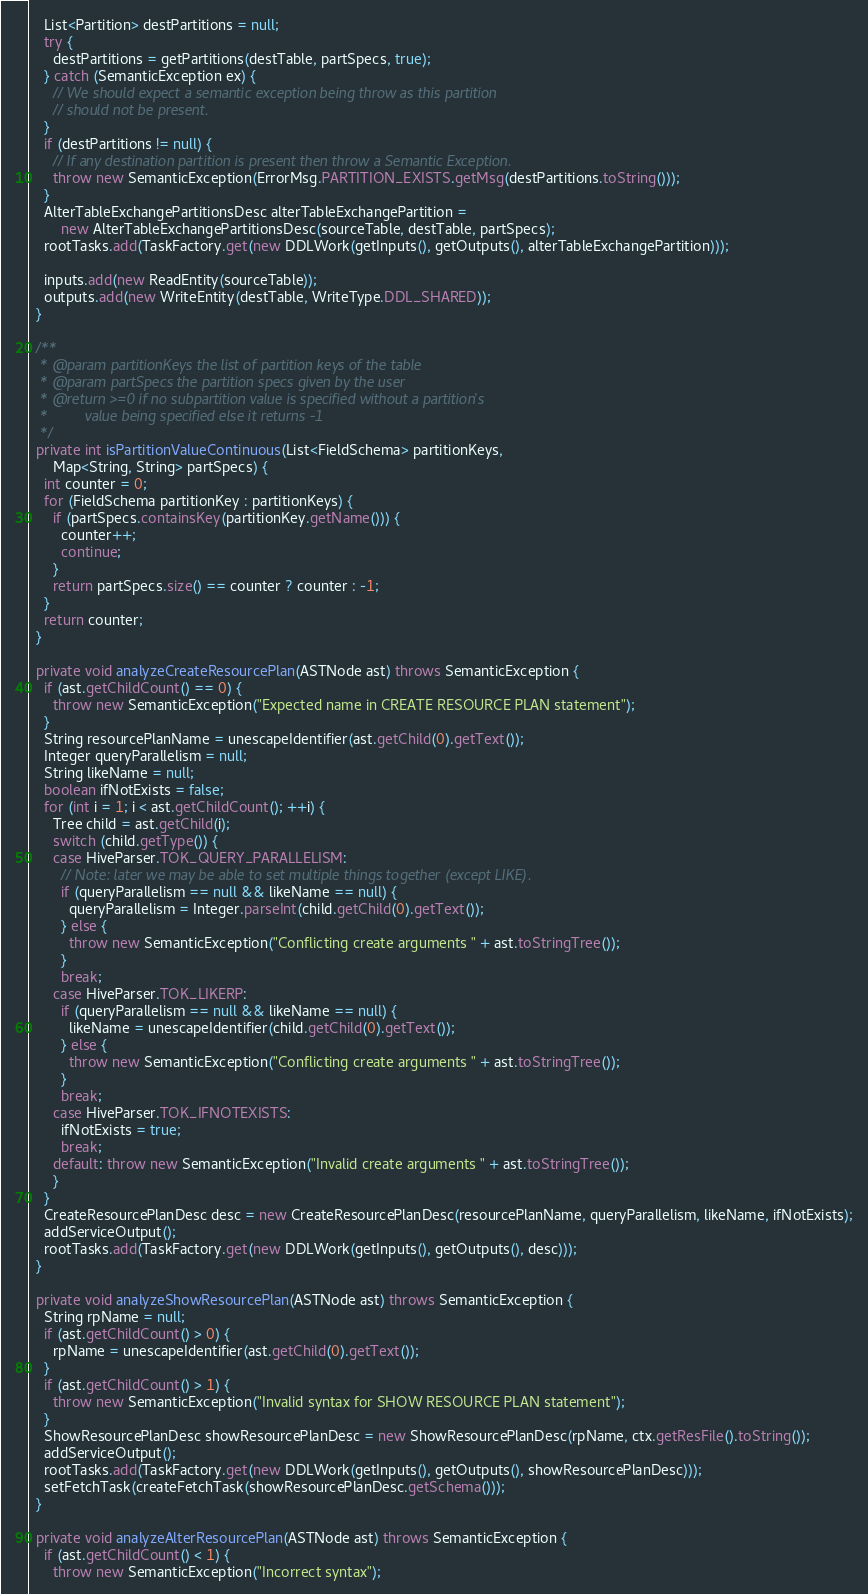Convert code to text. <code><loc_0><loc_0><loc_500><loc_500><_Java_>    List<Partition> destPartitions = null;
    try {
      destPartitions = getPartitions(destTable, partSpecs, true);
    } catch (SemanticException ex) {
      // We should expect a semantic exception being throw as this partition
      // should not be present.
    }
    if (destPartitions != null) {
      // If any destination partition is present then throw a Semantic Exception.
      throw new SemanticException(ErrorMsg.PARTITION_EXISTS.getMsg(destPartitions.toString()));
    }
    AlterTableExchangePartitionsDesc alterTableExchangePartition =
        new AlterTableExchangePartitionsDesc(sourceTable, destTable, partSpecs);
    rootTasks.add(TaskFactory.get(new DDLWork(getInputs(), getOutputs(), alterTableExchangePartition)));

    inputs.add(new ReadEntity(sourceTable));
    outputs.add(new WriteEntity(destTable, WriteType.DDL_SHARED));
  }

  /**
   * @param partitionKeys the list of partition keys of the table
   * @param partSpecs the partition specs given by the user
   * @return >=0 if no subpartition value is specified without a partition's
   *         value being specified else it returns -1
   */
  private int isPartitionValueContinuous(List<FieldSchema> partitionKeys,
      Map<String, String> partSpecs) {
    int counter = 0;
    for (FieldSchema partitionKey : partitionKeys) {
      if (partSpecs.containsKey(partitionKey.getName())) {
        counter++;
        continue;
      }
      return partSpecs.size() == counter ? counter : -1;
    }
    return counter;
  }

  private void analyzeCreateResourcePlan(ASTNode ast) throws SemanticException {
    if (ast.getChildCount() == 0) {
      throw new SemanticException("Expected name in CREATE RESOURCE PLAN statement");
    }
    String resourcePlanName = unescapeIdentifier(ast.getChild(0).getText());
    Integer queryParallelism = null;
    String likeName = null;
    boolean ifNotExists = false;
    for (int i = 1; i < ast.getChildCount(); ++i) {
      Tree child = ast.getChild(i);
      switch (child.getType()) {
      case HiveParser.TOK_QUERY_PARALLELISM:
        // Note: later we may be able to set multiple things together (except LIKE).
        if (queryParallelism == null && likeName == null) {
          queryParallelism = Integer.parseInt(child.getChild(0).getText());
        } else {
          throw new SemanticException("Conflicting create arguments " + ast.toStringTree());
        }
        break;
      case HiveParser.TOK_LIKERP:
        if (queryParallelism == null && likeName == null) {
          likeName = unescapeIdentifier(child.getChild(0).getText());
        } else {
          throw new SemanticException("Conflicting create arguments " + ast.toStringTree());
        }
        break;
      case HiveParser.TOK_IFNOTEXISTS:
        ifNotExists = true;
        break;
      default: throw new SemanticException("Invalid create arguments " + ast.toStringTree());
      }
    }
    CreateResourcePlanDesc desc = new CreateResourcePlanDesc(resourcePlanName, queryParallelism, likeName, ifNotExists);
    addServiceOutput();
    rootTasks.add(TaskFactory.get(new DDLWork(getInputs(), getOutputs(), desc)));
  }

  private void analyzeShowResourcePlan(ASTNode ast) throws SemanticException {
    String rpName = null;
    if (ast.getChildCount() > 0) {
      rpName = unescapeIdentifier(ast.getChild(0).getText());
    }
    if (ast.getChildCount() > 1) {
      throw new SemanticException("Invalid syntax for SHOW RESOURCE PLAN statement");
    }
    ShowResourcePlanDesc showResourcePlanDesc = new ShowResourcePlanDesc(rpName, ctx.getResFile().toString());
    addServiceOutput();
    rootTasks.add(TaskFactory.get(new DDLWork(getInputs(), getOutputs(), showResourcePlanDesc)));
    setFetchTask(createFetchTask(showResourcePlanDesc.getSchema()));
  }

  private void analyzeAlterResourcePlan(ASTNode ast) throws SemanticException {
    if (ast.getChildCount() < 1) {
      throw new SemanticException("Incorrect syntax");</code> 